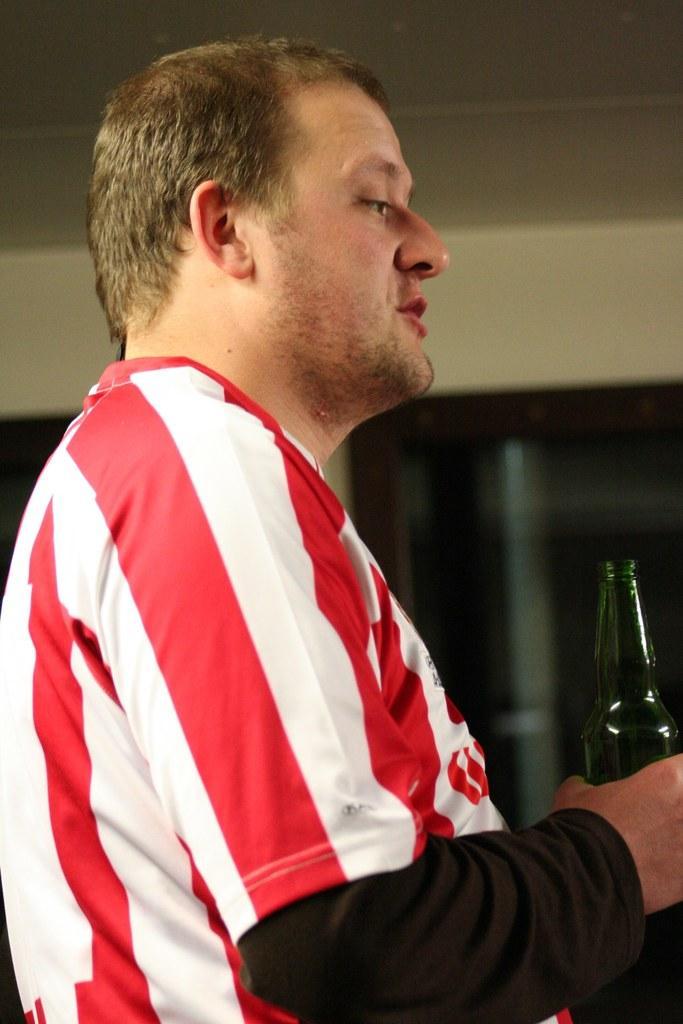Describe this image in one or two sentences. In this image I can see a man is holding a bottle in his hand. 